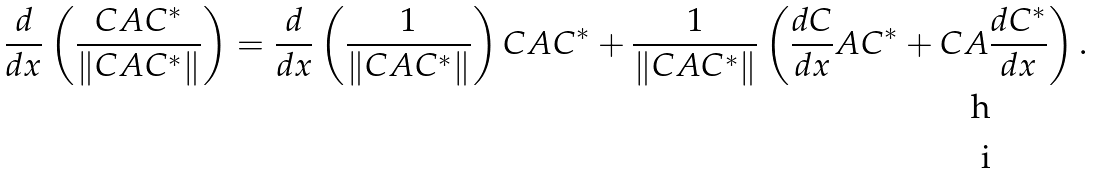<formula> <loc_0><loc_0><loc_500><loc_500>\frac { d } { d x } \left ( \frac { C A C ^ { * } } { \left \| C A C ^ { * } \right \| } \right ) = \ & \frac { d } { d x } \left ( \frac { 1 } { \left \| C A C ^ { * } \right \| } \right ) C A C ^ { * } + \frac { 1 } { \left \| C A C ^ { * } \right \| } \left ( \frac { d C } { d x } A C ^ { * } + C A \frac { d C ^ { * } } { d x } \right ) . \\</formula> 